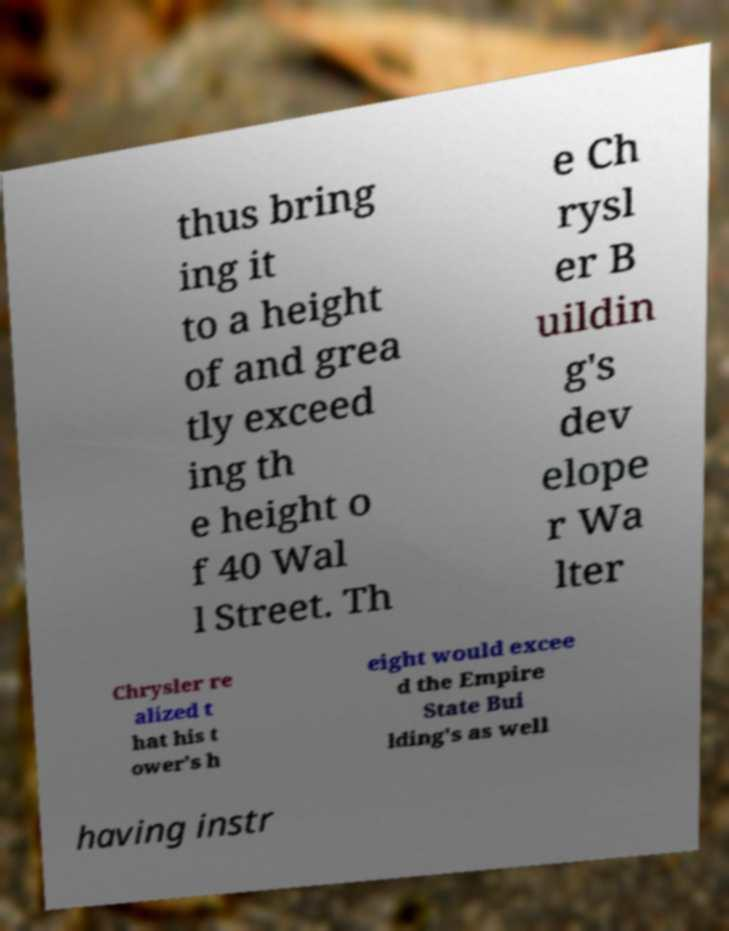Can you read and provide the text displayed in the image?This photo seems to have some interesting text. Can you extract and type it out for me? thus bring ing it to a height of and grea tly exceed ing th e height o f 40 Wal l Street. Th e Ch rysl er B uildin g's dev elope r Wa lter Chrysler re alized t hat his t ower's h eight would excee d the Empire State Bui lding's as well having instr 